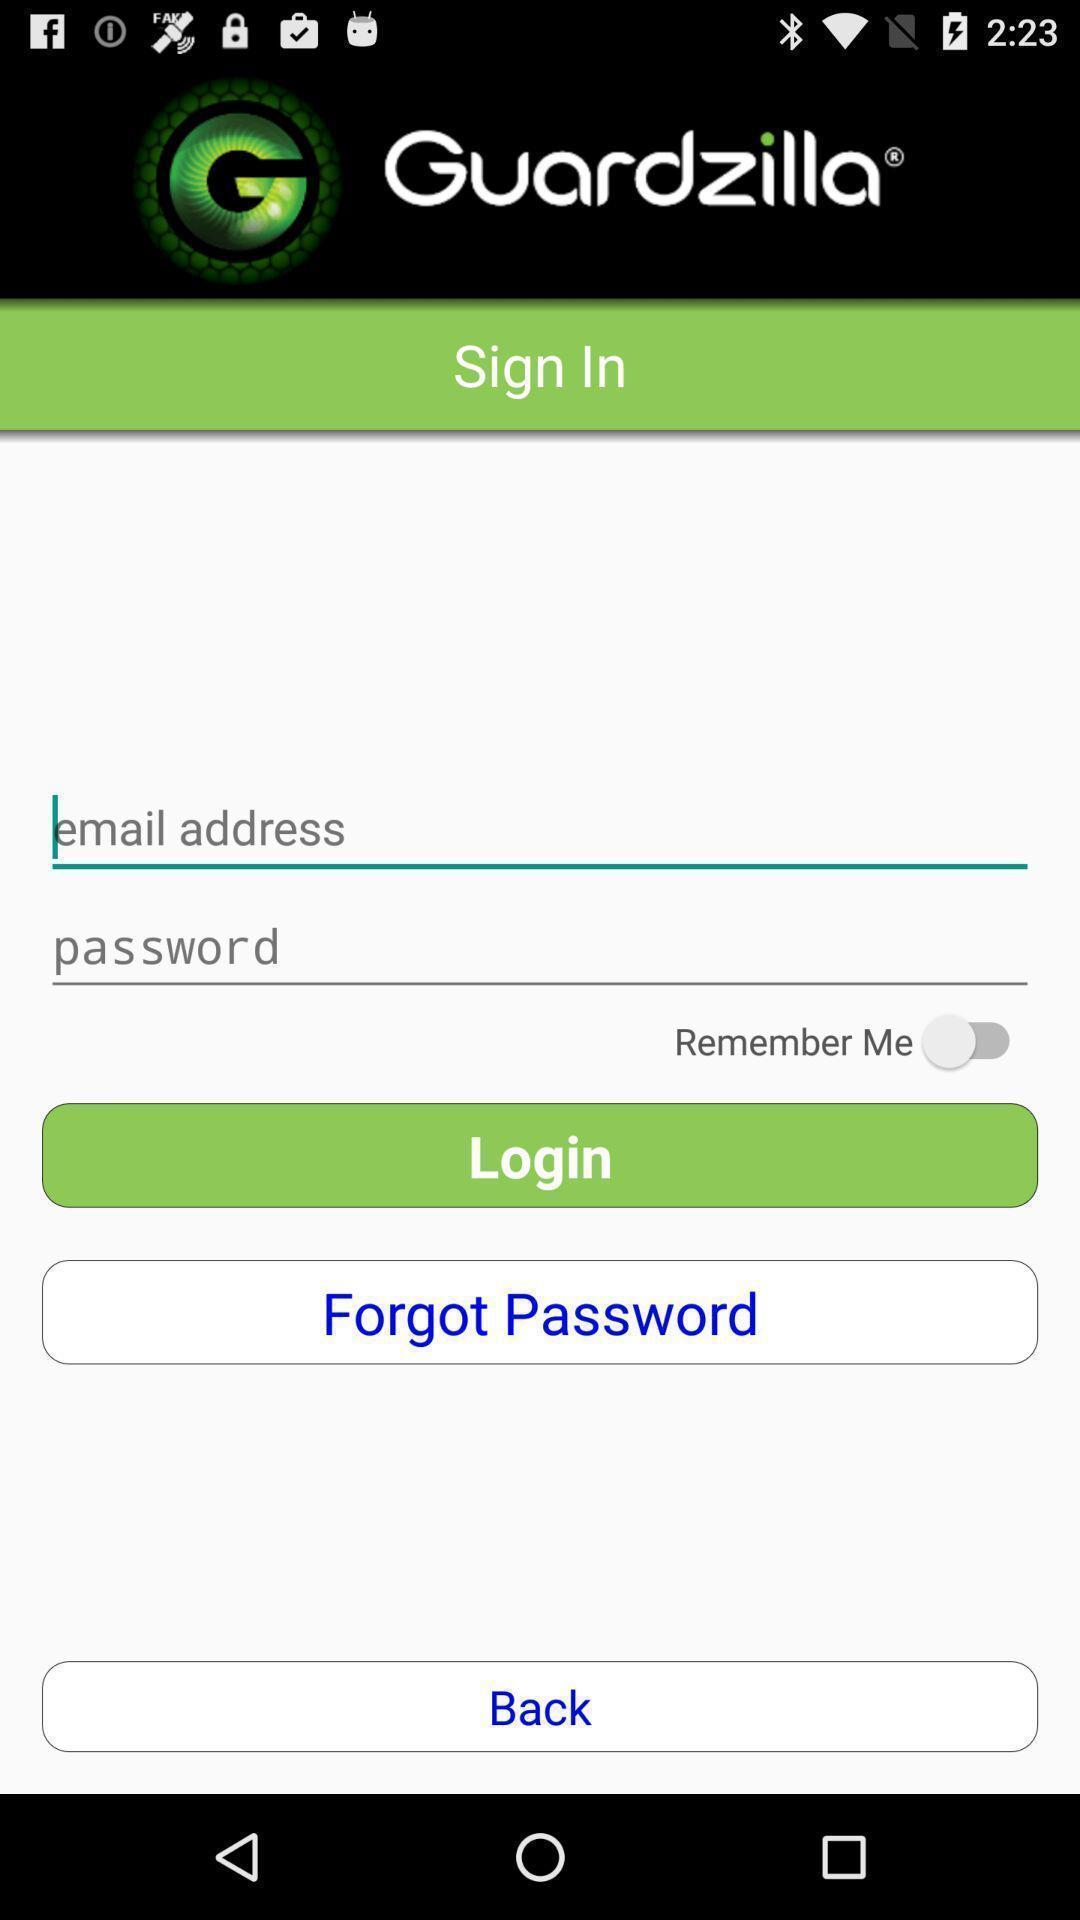Tell me about the visual elements in this screen capture. Page showing sign in page. 